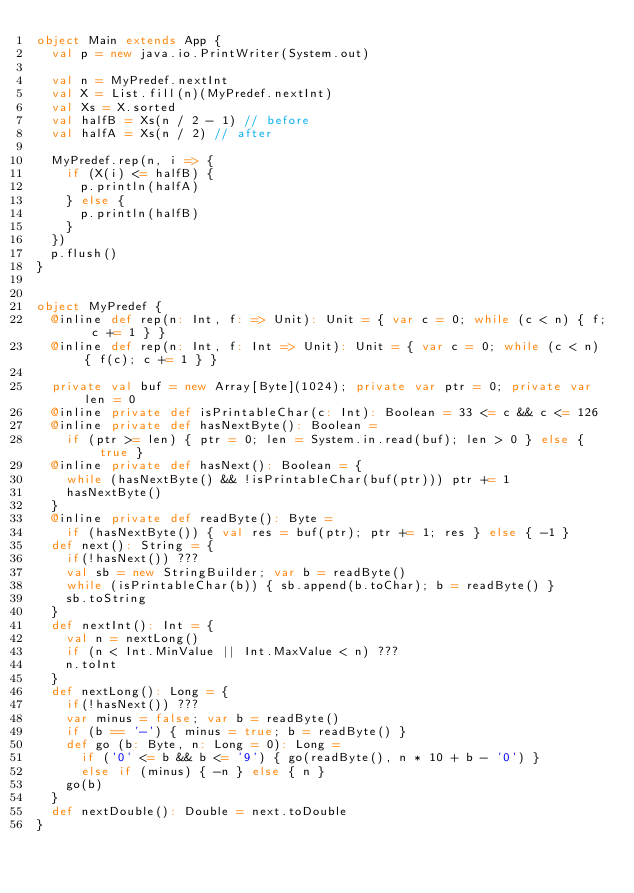<code> <loc_0><loc_0><loc_500><loc_500><_Scala_>object Main extends App {
  val p = new java.io.PrintWriter(System.out)

  val n = MyPredef.nextInt
  val X = List.fill(n)(MyPredef.nextInt)
  val Xs = X.sorted
  val halfB = Xs(n / 2 - 1) // before
  val halfA = Xs(n / 2) // after

  MyPredef.rep(n, i => {
    if (X(i) <= halfB) {
      p.println(halfA)
    } else {
      p.println(halfB)
    }
  })
  p.flush()
}


object MyPredef {
  @inline def rep(n: Int, f: => Unit): Unit = { var c = 0; while (c < n) { f; c += 1 } }
  @inline def rep(n: Int, f: Int => Unit): Unit = { var c = 0; while (c < n) { f(c); c += 1 } }

  private val buf = new Array[Byte](1024); private var ptr = 0; private var len = 0
  @inline private def isPrintableChar(c: Int): Boolean = 33 <= c && c <= 126
  @inline private def hasNextByte(): Boolean =
    if (ptr >= len) { ptr = 0; len = System.in.read(buf); len > 0 } else { true }
  @inline private def hasNext(): Boolean = {
    while (hasNextByte() && !isPrintableChar(buf(ptr))) ptr += 1
    hasNextByte()
  }
  @inline private def readByte(): Byte =
    if (hasNextByte()) { val res = buf(ptr); ptr += 1; res } else { -1 }
  def next(): String = {
    if(!hasNext()) ???
    val sb = new StringBuilder; var b = readByte()
    while (isPrintableChar(b)) { sb.append(b.toChar); b = readByte() }
    sb.toString
  }
  def nextInt(): Int = {
    val n = nextLong()
    if (n < Int.MinValue || Int.MaxValue < n) ???
    n.toInt
  }
  def nextLong(): Long = {
    if(!hasNext()) ???
    var minus = false; var b = readByte()
    if (b == '-') { minus = true; b = readByte() }
    def go (b: Byte, n: Long = 0): Long =
      if ('0' <= b && b <= '9') { go(readByte(), n * 10 + b - '0') }
      else if (minus) { -n } else { n }
    go(b)
  }
  def nextDouble(): Double = next.toDouble
}
</code> 